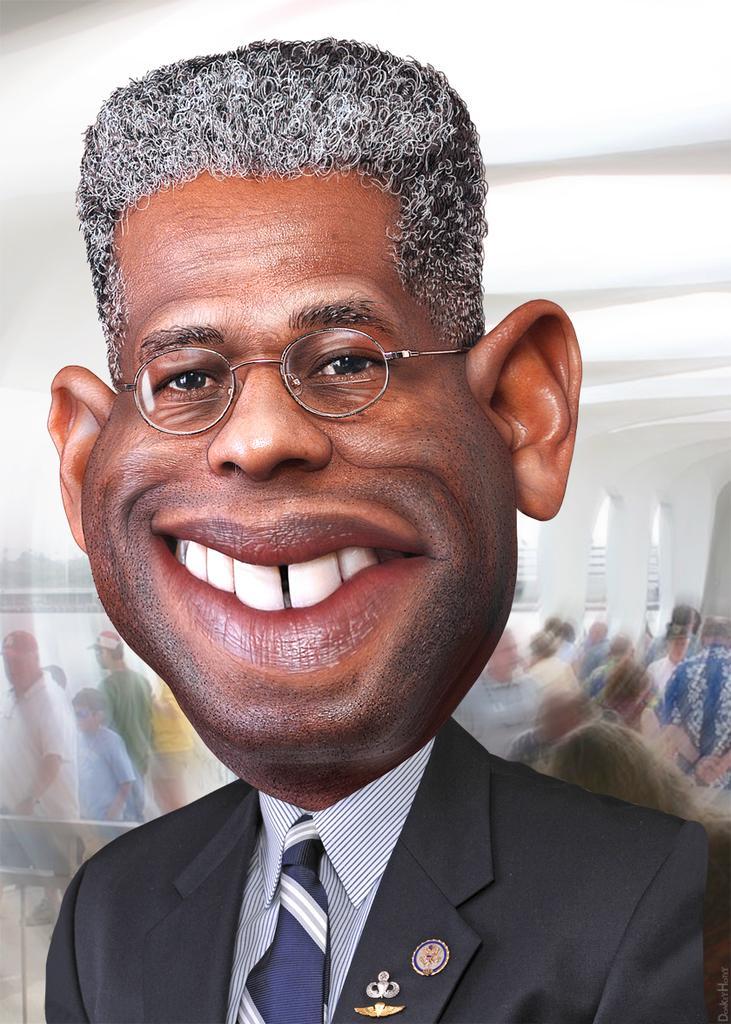Describe this image in one or two sentences. In the picture i can see a person wearing black color suit, also wearing suits standing and in the background there are some persons walking. 